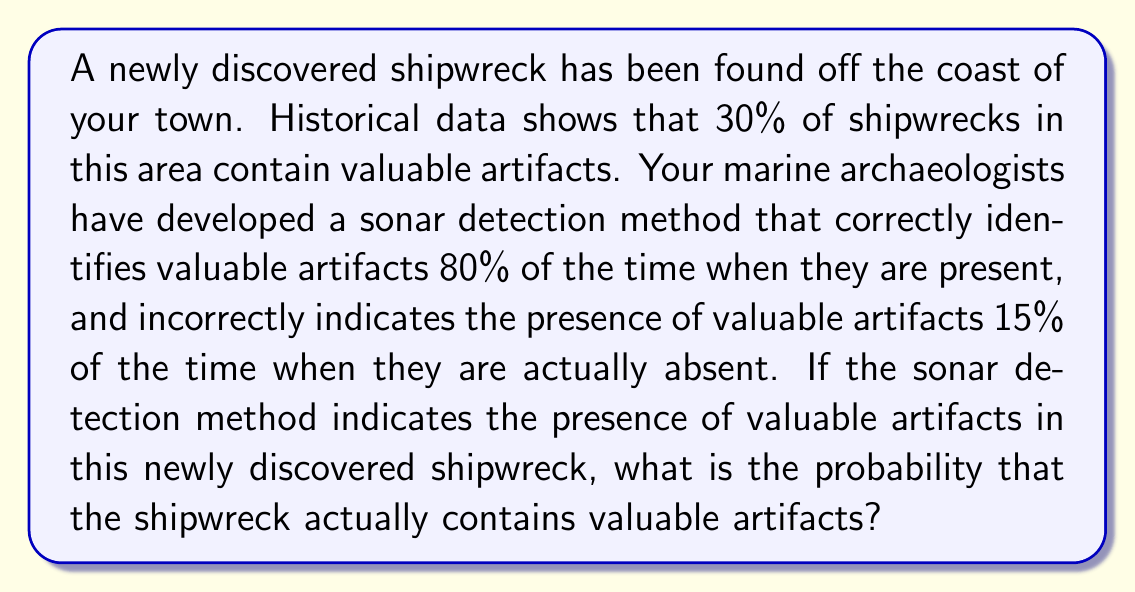Teach me how to tackle this problem. Let's approach this problem using Bayes' theorem. We'll define the following events:

A: The shipwreck contains valuable artifacts
B: The sonar detection method indicates the presence of valuable artifacts

We're given the following probabilities:

$P(A) = 0.30$ (prior probability of valuable artifacts)
$P(B|A) = 0.80$ (true positive rate)
$P(B|\neg A) = 0.15$ (false positive rate)

We want to find $P(A|B)$, which is the probability that the shipwreck contains valuable artifacts given that the sonar method indicates their presence.

Bayes' theorem states:

$$P(A|B) = \frac{P(B|A) \cdot P(A)}{P(B)}$$

To calculate $P(B)$, we use the law of total probability:

$$P(B) = P(B|A) \cdot P(A) + P(B|\neg A) \cdot P(\neg A)$$

First, let's calculate $P(\neg A)$:

$P(\neg A) = 1 - P(A) = 1 - 0.30 = 0.70$

Now, we can calculate $P(B)$:

$$\begin{align*}
P(B) &= 0.80 \cdot 0.30 + 0.15 \cdot 0.70 \\
&= 0.24 + 0.105 \\
&= 0.345
\end{align*}$$

Now we have all the components to apply Bayes' theorem:

$$\begin{align*}
P(A|B) &= \frac{P(B|A) \cdot P(A)}{P(B)} \\
&= \frac{0.80 \cdot 0.30}{0.345} \\
&= \frac{0.24}{0.345} \\
&\approx 0.6957
\end{align*}$$

Therefore, the probability that the shipwreck actually contains valuable artifacts, given that the sonar detection method indicates their presence, is approximately 0.6957 or 69.57%.
Answer: $P(A|B) \approx 0.6957$ or 69.57% 